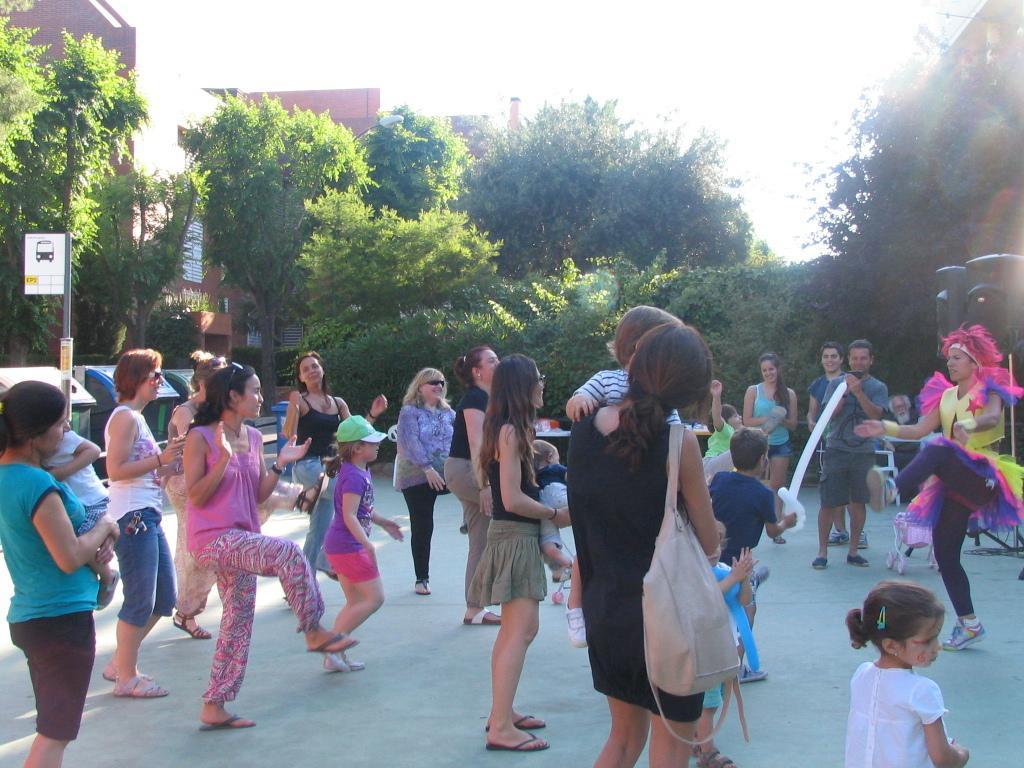Describe this image in one or two sentences. In the foreground of the picture there are many people dancing. In the center of the picture there are trees, speakers, sign board and dustbin. In the background there are buildings. It is sunny. 